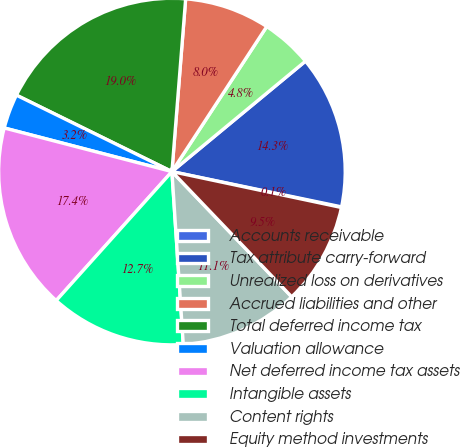Convert chart. <chart><loc_0><loc_0><loc_500><loc_500><pie_chart><fcel>Accounts receivable<fcel>Tax attribute carry-forward<fcel>Unrealized loss on derivatives<fcel>Accrued liabilities and other<fcel>Total deferred income tax<fcel>Valuation allowance<fcel>Net deferred income tax assets<fcel>Intangible assets<fcel>Content rights<fcel>Equity method investments<nl><fcel>0.06%<fcel>14.26%<fcel>4.79%<fcel>7.95%<fcel>18.99%<fcel>3.22%<fcel>17.41%<fcel>12.68%<fcel>11.1%<fcel>9.53%<nl></chart> 